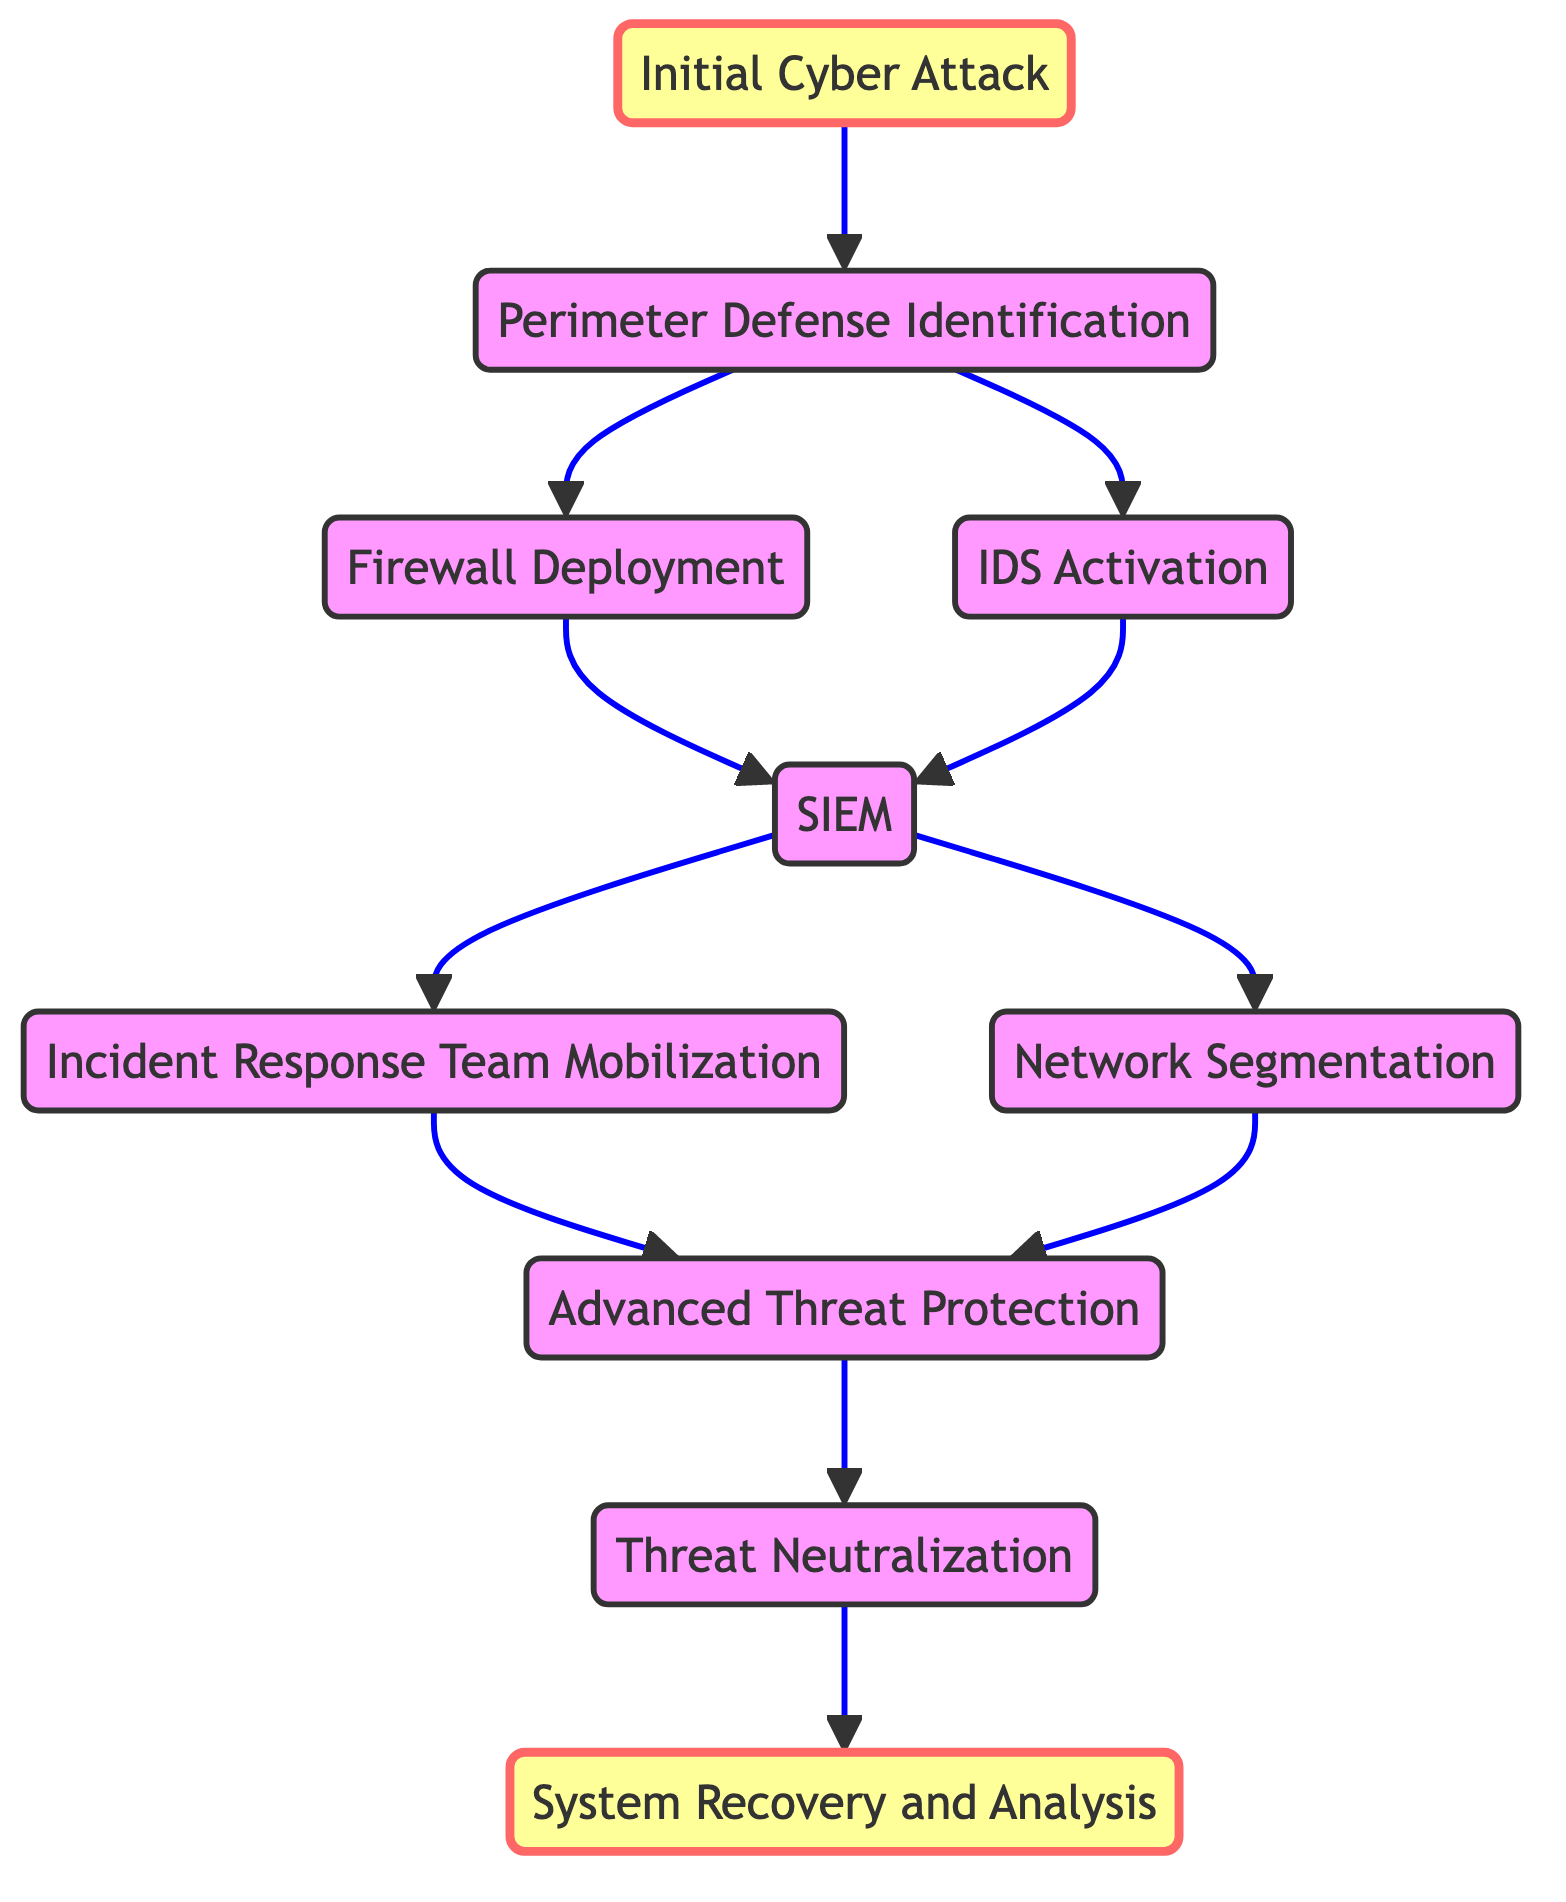What is the first step in the cyber defense flow chart? The flow chart starts with the "Initial Cyber Attack," which is represented as the first node.
Answer: Initial Cyber Attack How many nodes are there in the flow chart? By counting the elements listed in the data, we see there are 10 distinct nodes in total from the start to the final step.
Answer: 10 What are the two actions that can occur after "Perimeter Defense Identification"? The flow chart indicates two possible next steps, which are "Firewall Deployment" and "Intrusion Detection System (IDS) Activation," branching from the perimeter defense identification.
Answer: Firewall Deployment, Intrusion Detection System (IDS) Activation What is deployed after the "Security Information and Event Management (SIEM)" step? After the SIEM step, the flow indicates that either "Incident Response Team Mobilization" or "Network Segmentation" can occur next, showing the possible pathways from the SIEM node.
Answer: Incident Response Team Mobilization, Network Segmentation What is the last step in the cyber defense process represented in the flow chart? The final step in the flow chart is "System Recovery and Analysis," which concludes the defense process following all previous actions taken to neutralize threats.
Answer: System Recovery and Analysis How does the "Advanced Threat Protection" node relate to the nodes before it? The "Advanced Threat Protection" node follows both the "Incident Response Team Mobilization" and "Network Segmentation" nodes, indicating it is a subsequent step that can be reached from either of those defenses.
Answer: It follows both the Incident Response Team Mobilization and Network Segmentation nodes Which defensive measure aims to neutralize threats? The step labeled "Threat Neutralization" specifically addresses the actions taken to neutralize any detected cyber threats that arise during the cyber defense process.
Answer: Threat Neutralization What flow connections branch from the "SIEM" node? The "SIEM" node branches out to two nodes: "Incident Response Team Mobilization" and "Network Segmentation," representing the next possible actions after SIEM.
Answer: Incident Response Team Mobilization, Network Segmentation 